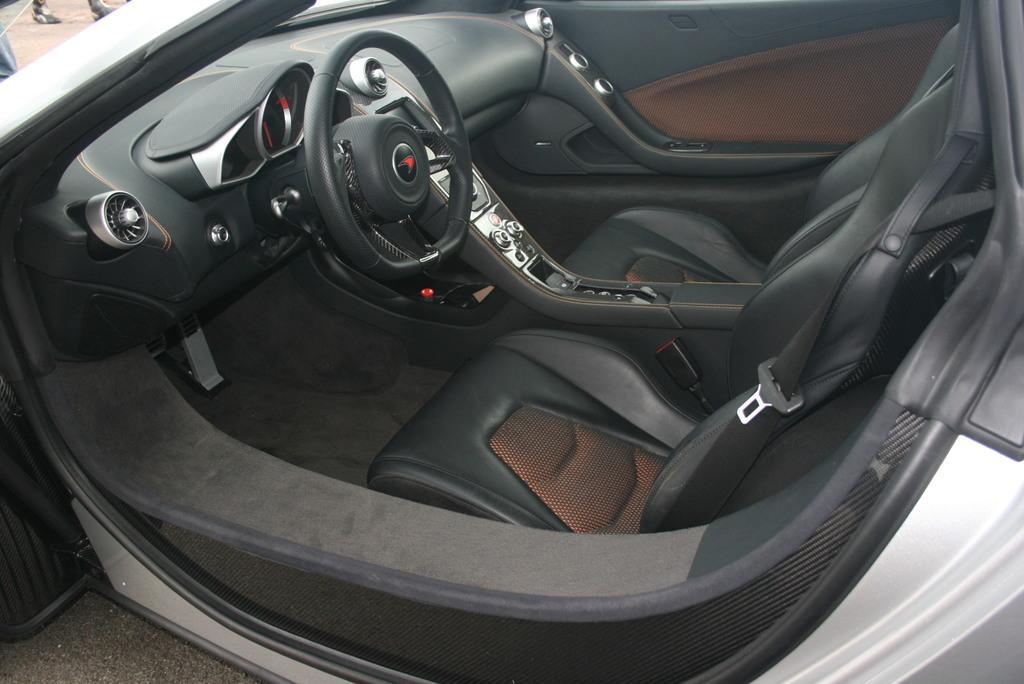Can you describe this image briefly? This image is taken outdoors. At the bottom of the image there is a road. In the middle of the image there is a car. At the top left of the image there is a person. 